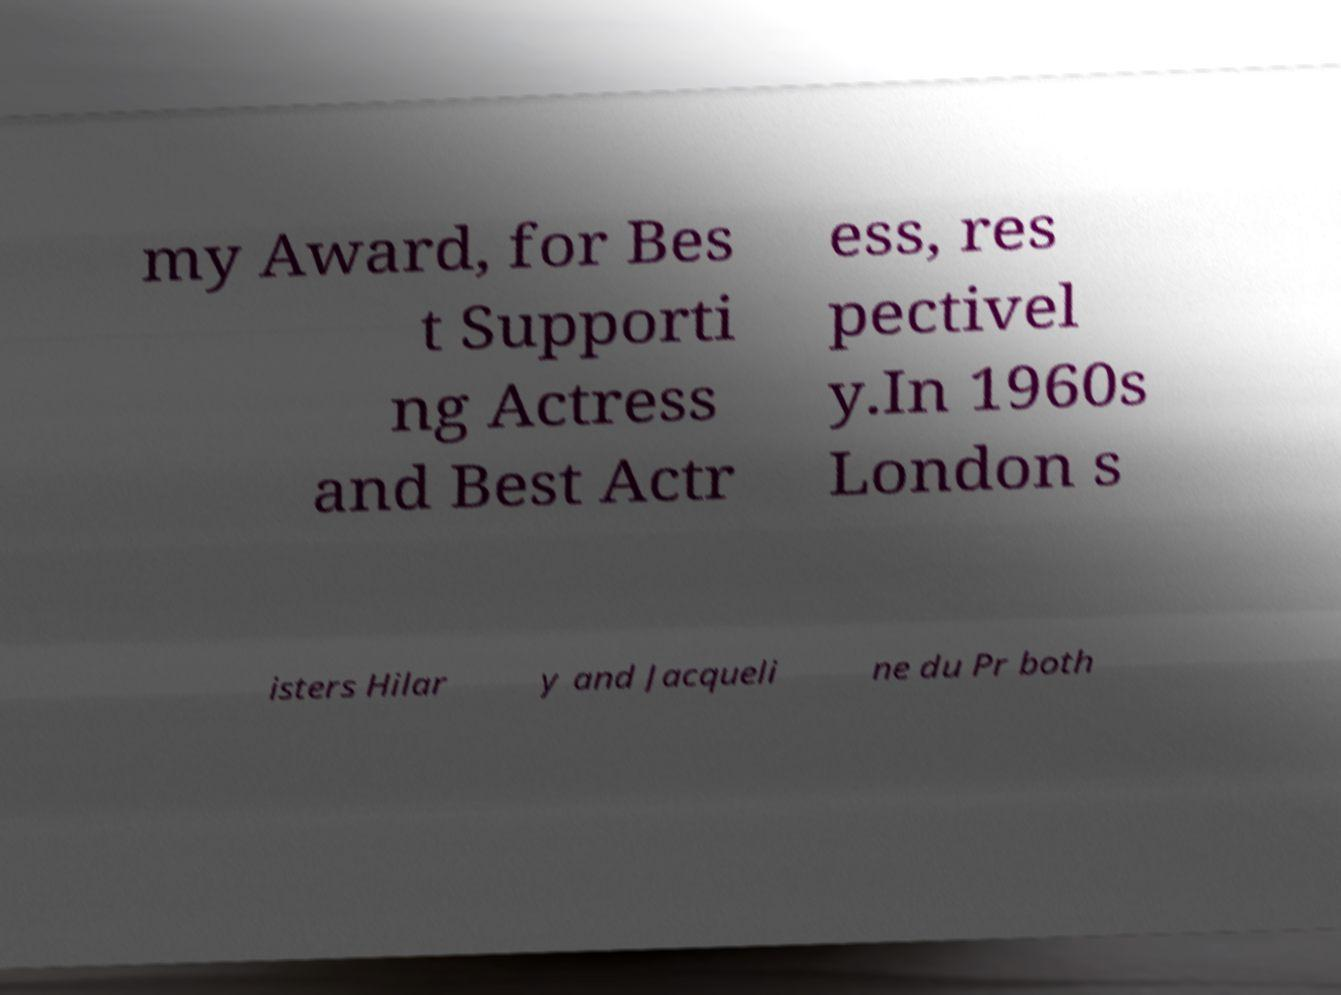For documentation purposes, I need the text within this image transcribed. Could you provide that? my Award, for Bes t Supporti ng Actress and Best Actr ess, res pectivel y.In 1960s London s isters Hilar y and Jacqueli ne du Pr both 